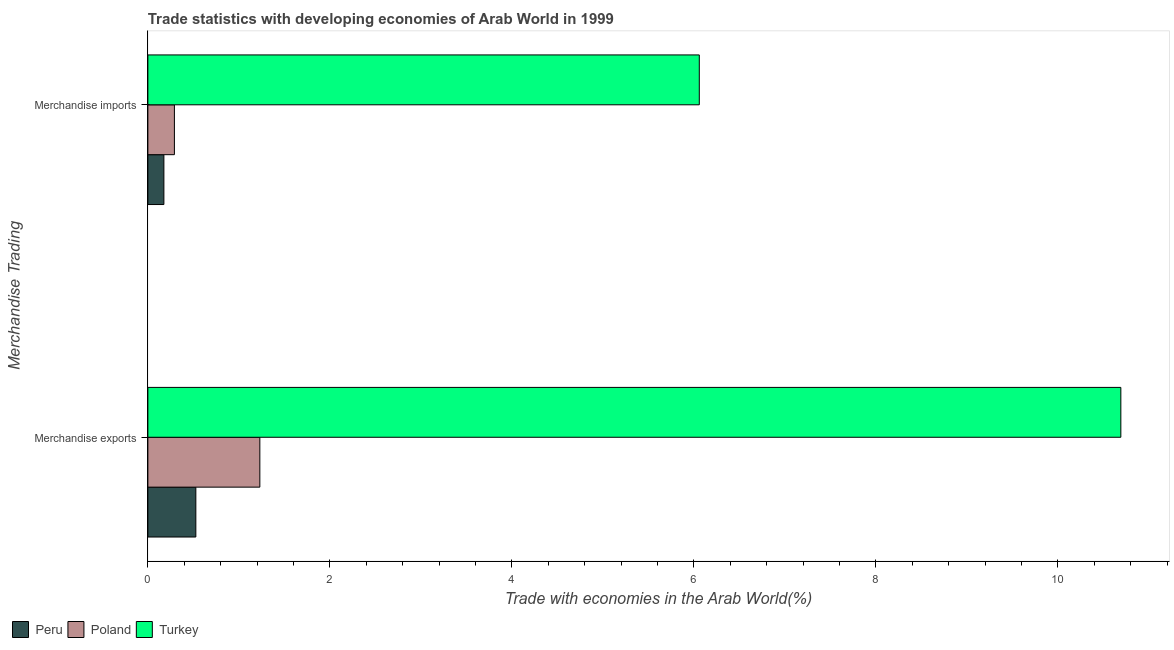How many different coloured bars are there?
Make the answer very short. 3. What is the merchandise exports in Poland?
Make the answer very short. 1.23. Across all countries, what is the maximum merchandise imports?
Offer a terse response. 6.06. Across all countries, what is the minimum merchandise exports?
Offer a very short reply. 0.53. In which country was the merchandise imports maximum?
Your answer should be compact. Turkey. In which country was the merchandise imports minimum?
Provide a succinct answer. Peru. What is the total merchandise exports in the graph?
Your response must be concise. 12.45. What is the difference between the merchandise exports in Peru and that in Poland?
Keep it short and to the point. -0.7. What is the difference between the merchandise imports in Peru and the merchandise exports in Poland?
Your response must be concise. -1.05. What is the average merchandise exports per country?
Your answer should be compact. 4.15. What is the difference between the merchandise exports and merchandise imports in Turkey?
Offer a terse response. 4.63. In how many countries, is the merchandise exports greater than 3.2 %?
Give a very brief answer. 1. What is the ratio of the merchandise exports in Turkey to that in Peru?
Make the answer very short. 20.28. What does the 2nd bar from the top in Merchandise exports represents?
Provide a short and direct response. Poland. How many bars are there?
Offer a terse response. 6. Are all the bars in the graph horizontal?
Your answer should be very brief. Yes. What is the difference between two consecutive major ticks on the X-axis?
Ensure brevity in your answer.  2. Does the graph contain grids?
Keep it short and to the point. No. Where does the legend appear in the graph?
Provide a succinct answer. Bottom left. How many legend labels are there?
Your answer should be very brief. 3. What is the title of the graph?
Make the answer very short. Trade statistics with developing economies of Arab World in 1999. What is the label or title of the X-axis?
Offer a terse response. Trade with economies in the Arab World(%). What is the label or title of the Y-axis?
Your answer should be very brief. Merchandise Trading. What is the Trade with economies in the Arab World(%) of Peru in Merchandise exports?
Provide a short and direct response. 0.53. What is the Trade with economies in the Arab World(%) of Poland in Merchandise exports?
Your response must be concise. 1.23. What is the Trade with economies in the Arab World(%) in Turkey in Merchandise exports?
Offer a very short reply. 10.69. What is the Trade with economies in the Arab World(%) of Peru in Merchandise imports?
Provide a succinct answer. 0.18. What is the Trade with economies in the Arab World(%) in Poland in Merchandise imports?
Your answer should be very brief. 0.29. What is the Trade with economies in the Arab World(%) of Turkey in Merchandise imports?
Provide a succinct answer. 6.06. Across all Merchandise Trading, what is the maximum Trade with economies in the Arab World(%) in Peru?
Provide a short and direct response. 0.53. Across all Merchandise Trading, what is the maximum Trade with economies in the Arab World(%) of Poland?
Provide a short and direct response. 1.23. Across all Merchandise Trading, what is the maximum Trade with economies in the Arab World(%) in Turkey?
Your answer should be very brief. 10.69. Across all Merchandise Trading, what is the minimum Trade with economies in the Arab World(%) of Peru?
Offer a very short reply. 0.18. Across all Merchandise Trading, what is the minimum Trade with economies in the Arab World(%) in Poland?
Ensure brevity in your answer.  0.29. Across all Merchandise Trading, what is the minimum Trade with economies in the Arab World(%) of Turkey?
Your response must be concise. 6.06. What is the total Trade with economies in the Arab World(%) in Peru in the graph?
Provide a short and direct response. 0.7. What is the total Trade with economies in the Arab World(%) of Poland in the graph?
Make the answer very short. 1.52. What is the total Trade with economies in the Arab World(%) of Turkey in the graph?
Give a very brief answer. 16.75. What is the difference between the Trade with economies in the Arab World(%) in Peru in Merchandise exports and that in Merchandise imports?
Give a very brief answer. 0.35. What is the difference between the Trade with economies in the Arab World(%) in Poland in Merchandise exports and that in Merchandise imports?
Ensure brevity in your answer.  0.94. What is the difference between the Trade with economies in the Arab World(%) of Turkey in Merchandise exports and that in Merchandise imports?
Offer a very short reply. 4.63. What is the difference between the Trade with economies in the Arab World(%) in Peru in Merchandise exports and the Trade with economies in the Arab World(%) in Poland in Merchandise imports?
Your answer should be very brief. 0.24. What is the difference between the Trade with economies in the Arab World(%) of Peru in Merchandise exports and the Trade with economies in the Arab World(%) of Turkey in Merchandise imports?
Your answer should be very brief. -5.53. What is the difference between the Trade with economies in the Arab World(%) of Poland in Merchandise exports and the Trade with economies in the Arab World(%) of Turkey in Merchandise imports?
Your answer should be very brief. -4.83. What is the average Trade with economies in the Arab World(%) of Peru per Merchandise Trading?
Keep it short and to the point. 0.35. What is the average Trade with economies in the Arab World(%) of Poland per Merchandise Trading?
Offer a very short reply. 0.76. What is the average Trade with economies in the Arab World(%) of Turkey per Merchandise Trading?
Your answer should be compact. 8.37. What is the difference between the Trade with economies in the Arab World(%) in Peru and Trade with economies in the Arab World(%) in Poland in Merchandise exports?
Offer a very short reply. -0.7. What is the difference between the Trade with economies in the Arab World(%) in Peru and Trade with economies in the Arab World(%) in Turkey in Merchandise exports?
Your answer should be very brief. -10.16. What is the difference between the Trade with economies in the Arab World(%) of Poland and Trade with economies in the Arab World(%) of Turkey in Merchandise exports?
Make the answer very short. -9.46. What is the difference between the Trade with economies in the Arab World(%) of Peru and Trade with economies in the Arab World(%) of Poland in Merchandise imports?
Keep it short and to the point. -0.12. What is the difference between the Trade with economies in the Arab World(%) of Peru and Trade with economies in the Arab World(%) of Turkey in Merchandise imports?
Your answer should be compact. -5.88. What is the difference between the Trade with economies in the Arab World(%) in Poland and Trade with economies in the Arab World(%) in Turkey in Merchandise imports?
Provide a short and direct response. -5.77. What is the ratio of the Trade with economies in the Arab World(%) in Peru in Merchandise exports to that in Merchandise imports?
Your answer should be compact. 3. What is the ratio of the Trade with economies in the Arab World(%) in Poland in Merchandise exports to that in Merchandise imports?
Provide a succinct answer. 4.22. What is the ratio of the Trade with economies in the Arab World(%) of Turkey in Merchandise exports to that in Merchandise imports?
Your answer should be very brief. 1.76. What is the difference between the highest and the second highest Trade with economies in the Arab World(%) of Peru?
Your answer should be compact. 0.35. What is the difference between the highest and the second highest Trade with economies in the Arab World(%) of Poland?
Provide a succinct answer. 0.94. What is the difference between the highest and the second highest Trade with economies in the Arab World(%) in Turkey?
Make the answer very short. 4.63. What is the difference between the highest and the lowest Trade with economies in the Arab World(%) in Peru?
Offer a terse response. 0.35. What is the difference between the highest and the lowest Trade with economies in the Arab World(%) in Poland?
Offer a terse response. 0.94. What is the difference between the highest and the lowest Trade with economies in the Arab World(%) of Turkey?
Give a very brief answer. 4.63. 